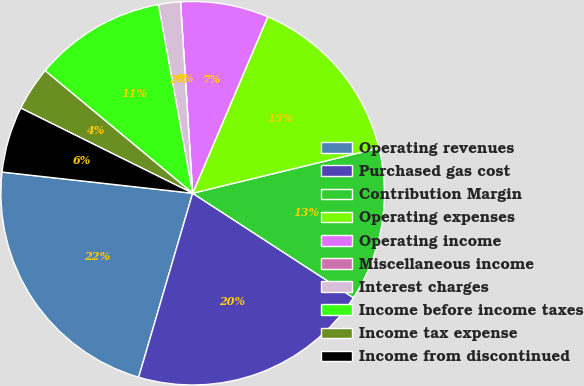Convert chart. <chart><loc_0><loc_0><loc_500><loc_500><pie_chart><fcel>Operating revenues<fcel>Purchased gas cost<fcel>Contribution Margin<fcel>Operating expenses<fcel>Operating income<fcel>Miscellaneous income<fcel>Interest charges<fcel>Income before income taxes<fcel>Income tax expense<fcel>Income from discontinued<nl><fcel>22.22%<fcel>20.37%<fcel>12.96%<fcel>14.81%<fcel>7.41%<fcel>0.0%<fcel>1.85%<fcel>11.11%<fcel>3.71%<fcel>5.56%<nl></chart> 